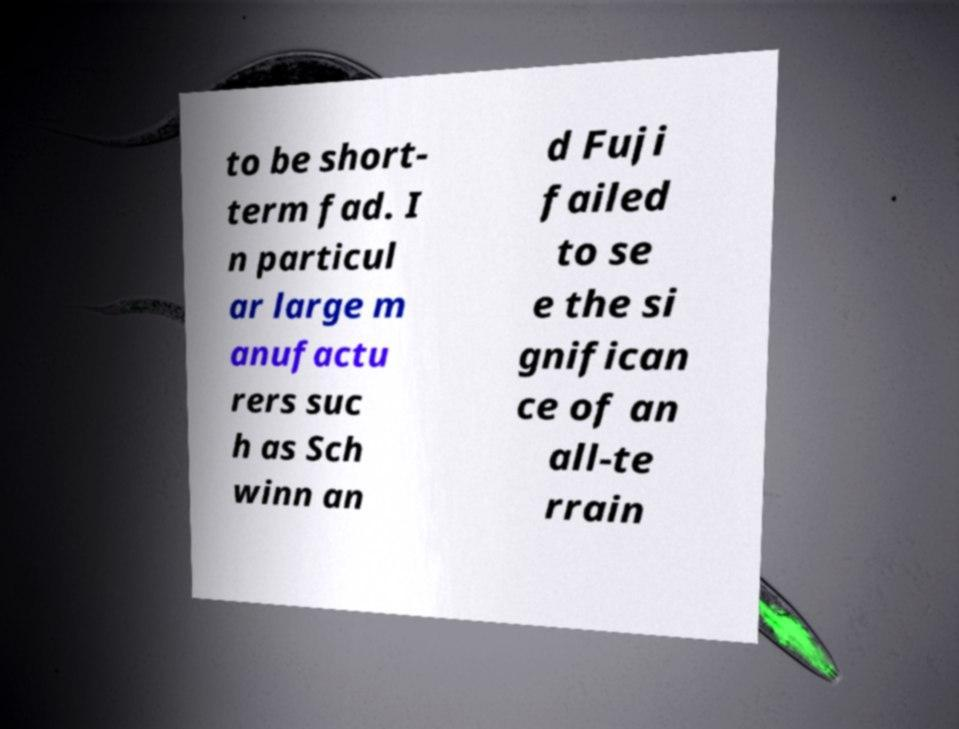Can you read and provide the text displayed in the image?This photo seems to have some interesting text. Can you extract and type it out for me? to be short- term fad. I n particul ar large m anufactu rers suc h as Sch winn an d Fuji failed to se e the si gnifican ce of an all-te rrain 